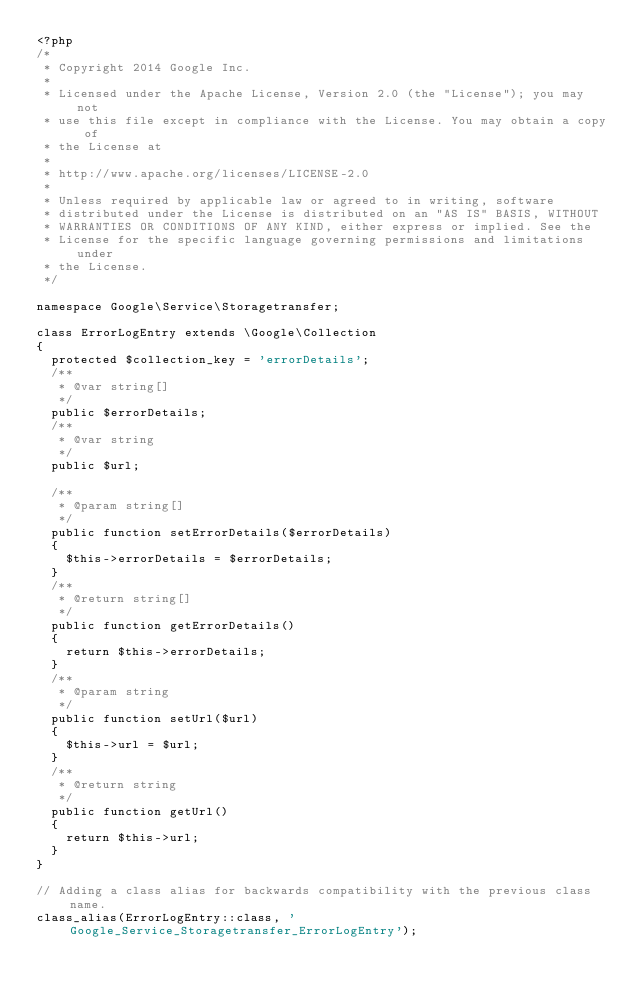Convert code to text. <code><loc_0><loc_0><loc_500><loc_500><_PHP_><?php
/*
 * Copyright 2014 Google Inc.
 *
 * Licensed under the Apache License, Version 2.0 (the "License"); you may not
 * use this file except in compliance with the License. You may obtain a copy of
 * the License at
 *
 * http://www.apache.org/licenses/LICENSE-2.0
 *
 * Unless required by applicable law or agreed to in writing, software
 * distributed under the License is distributed on an "AS IS" BASIS, WITHOUT
 * WARRANTIES OR CONDITIONS OF ANY KIND, either express or implied. See the
 * License for the specific language governing permissions and limitations under
 * the License.
 */

namespace Google\Service\Storagetransfer;

class ErrorLogEntry extends \Google\Collection
{
  protected $collection_key = 'errorDetails';
  /**
   * @var string[]
   */
  public $errorDetails;
  /**
   * @var string
   */
  public $url;

  /**
   * @param string[]
   */
  public function setErrorDetails($errorDetails)
  {
    $this->errorDetails = $errorDetails;
  }
  /**
   * @return string[]
   */
  public function getErrorDetails()
  {
    return $this->errorDetails;
  }
  /**
   * @param string
   */
  public function setUrl($url)
  {
    $this->url = $url;
  }
  /**
   * @return string
   */
  public function getUrl()
  {
    return $this->url;
  }
}

// Adding a class alias for backwards compatibility with the previous class name.
class_alias(ErrorLogEntry::class, 'Google_Service_Storagetransfer_ErrorLogEntry');
</code> 